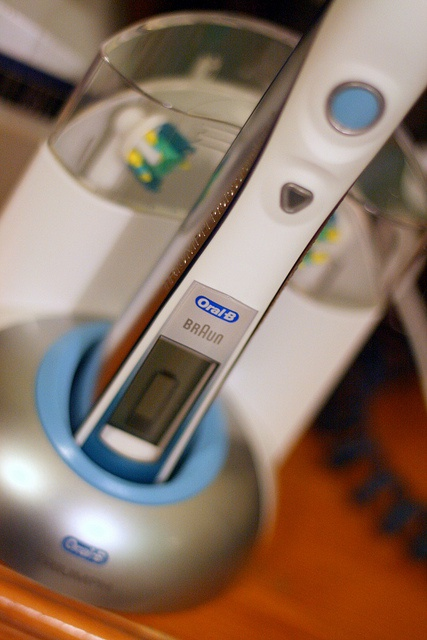Describe the objects in this image and their specific colors. I can see toothbrush in gray, darkgray, and lightgray tones and toothbrush in gray, tan, darkgray, and teal tones in this image. 